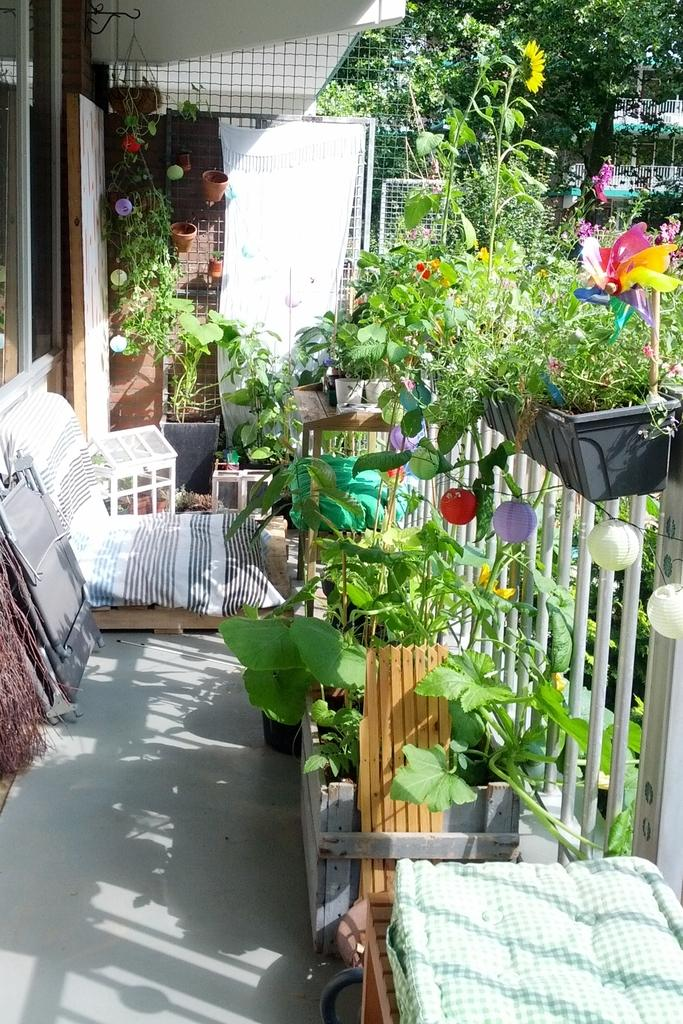What type of vegetation is present near the house in the image? The background of the image is greenery, which suggests that there are trees and other plants near the house. What can be found inside the house? There is a flower vase, flowers, stools, tables, and bed sheets inside the house. What type of furniture is present in the house? There are stools and tables in the house. What is used to cover the beds in the house? Bed sheets are present in the house. What type of barrier surrounds the house? There is fencing around the house. Can you see a cart being pushed by a goose in the image? No, there is no cart or goose present in the image. 